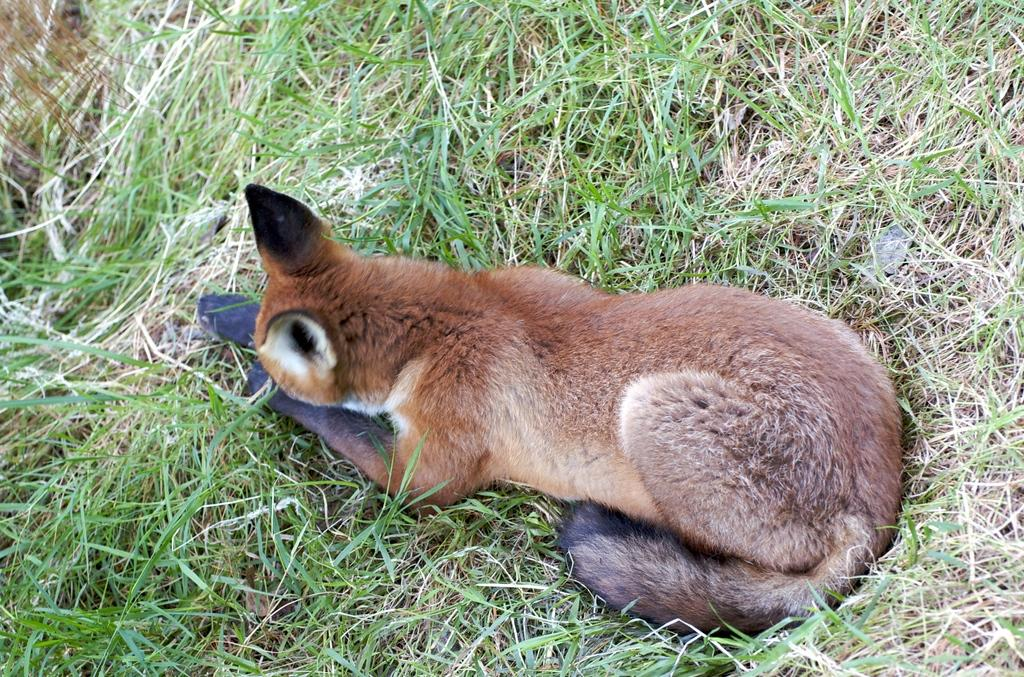What type of creature is in the image? There is an animal in the image. Where is the animal located in the image? The animal is sitting on the grass. What type of pies can be seen in the image? There are no pies present in the image; it features an animal sitting on the grass. How many snails are visible in the image? There are no snails visible in the image. 